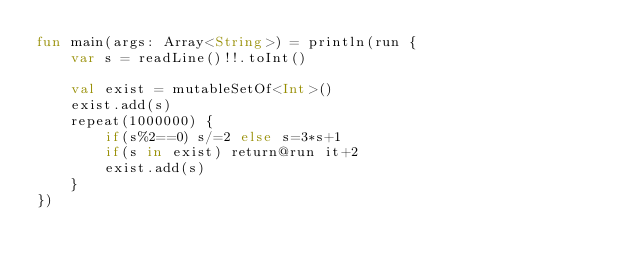<code> <loc_0><loc_0><loc_500><loc_500><_Kotlin_>fun main(args: Array<String>) = println(run {
    var s = readLine()!!.toInt()

    val exist = mutableSetOf<Int>()
    exist.add(s)
    repeat(1000000) {
        if(s%2==0) s/=2 else s=3*s+1
        if(s in exist) return@run it+2
        exist.add(s)
    }
})
</code> 